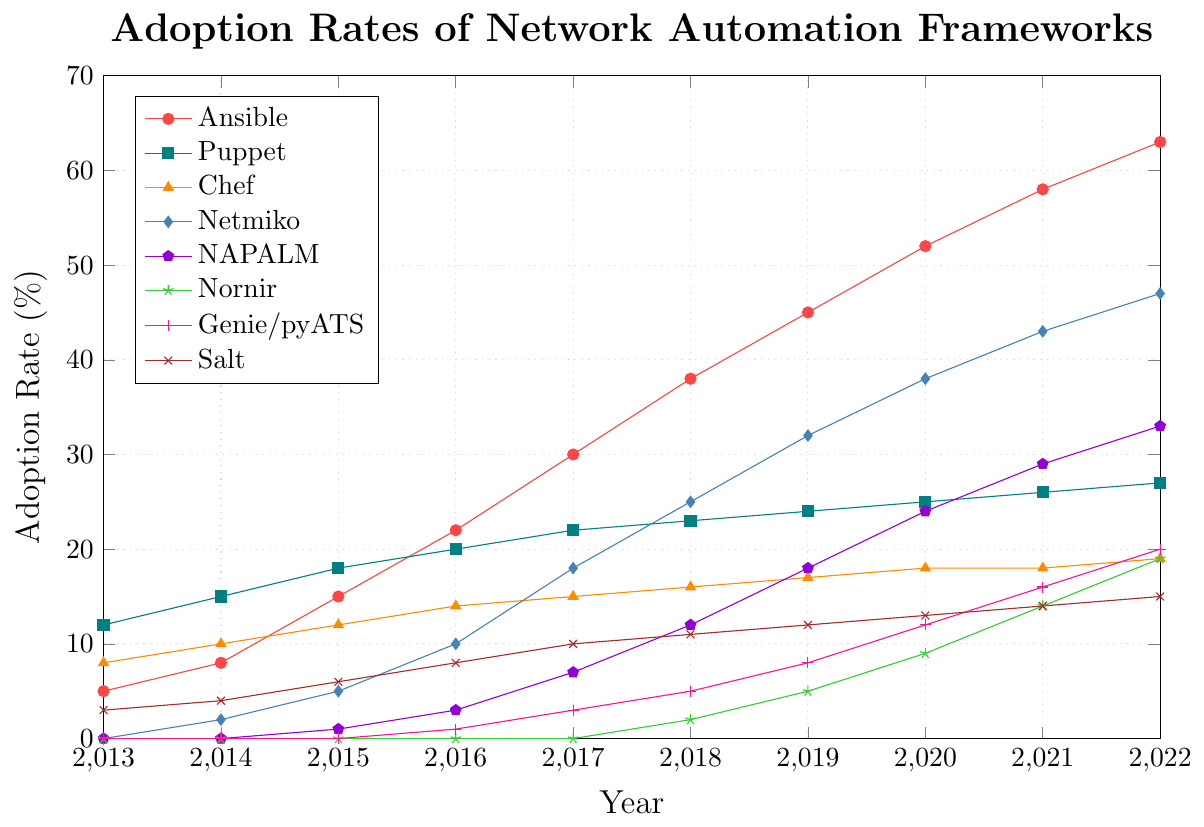When did Ansible surpass Puppet in adoption rate? To find out when Ansible surpassed Puppet, check the lines representing Ansible and Puppet on the chart. The Ansible line first crosses above the Puppet line between 2018 and 2019.
Answer: Between 2018 and 2019 Which framework had the most consistent increase in adoption rate from 2013 to 2022? Evaluate the slopes of the lines for each framework over the years. The line for Salt shows a steady and consistent increase over time without sharp spikes.
Answer: Salt What is the difference in adoption rates between Netmiko and NAPALM in 2022? Check the adoption rates for Netmiko and NAPALM in 2022. Netmiko has an adoption rate of 47%, and NAPALM has 33%. The difference is 47 - 33.
Answer: 14% Which framework showed the most dramatic rise in adoption rate between 2016 and 2017? Compare the slopes of the lines between 2016 and 2017. Netmiko shows the steepest rise from 10% to 18%.
Answer: Netmiko What is the total adoption rate for all frameworks in 2020? Sum the adoption rates of all frameworks for the year 2020: Ansible (52), Puppet (25), Chef (18), Netmiko (38), NAPALM (24), Nornir (9), Genie/pyATS (12), Salt (13). Total is 52 + 25 + 18 + 38 + 24 + 9 + 12 + 13.
Answer: 191% Which framework has the least adoption rate in 2022? Identify the framework with the smallest value for 2022. Nornir has the least adoption rate with 19%.
Answer: Nornir How much did the adoption rate of Genie/pyATS increase from 2017 to 2022? For Genie/pyATS, check the values in 2017 and 2022. The adoption rate increased from 3% in 2017 to 20% in 2022. The increase is 20 - 3.
Answer: 17% What is the average adoption rate of Ansible over the decade shown in the plot? Sum up Ansible's adoption rates from 2013 to 2022 (5 + 8 + 15 + 22 + 30 + 38 + 45 + 52 + 58 + 63) and then divide by the number of years (10). The sum is 336. The average is 336 / 10.
Answer: 33.6% Which two frameworks had a similar adoption rate in 2015, and what were their rates? Check the adoption rates for 2015 and find similar values. Puppet has 18% and Chef has 12%; although not exact, these rates are closer in value compared to other frameworks for that year.
Answer: Puppet and Chef at 18% and 12% Which framework's line color is green and how did its adoption rate change from 2018 to 2021? Identify the color-coded line that is green, which corresponds to Nornir. Check its adoption rates from 2% in 2018 to 14% in 2021.
Answer: Nornir, increased from 2% to 14% 